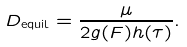<formula> <loc_0><loc_0><loc_500><loc_500>D _ { \text {equil} } = \frac { \mu } { 2 g ( F ) h ( \tau ) } .</formula> 